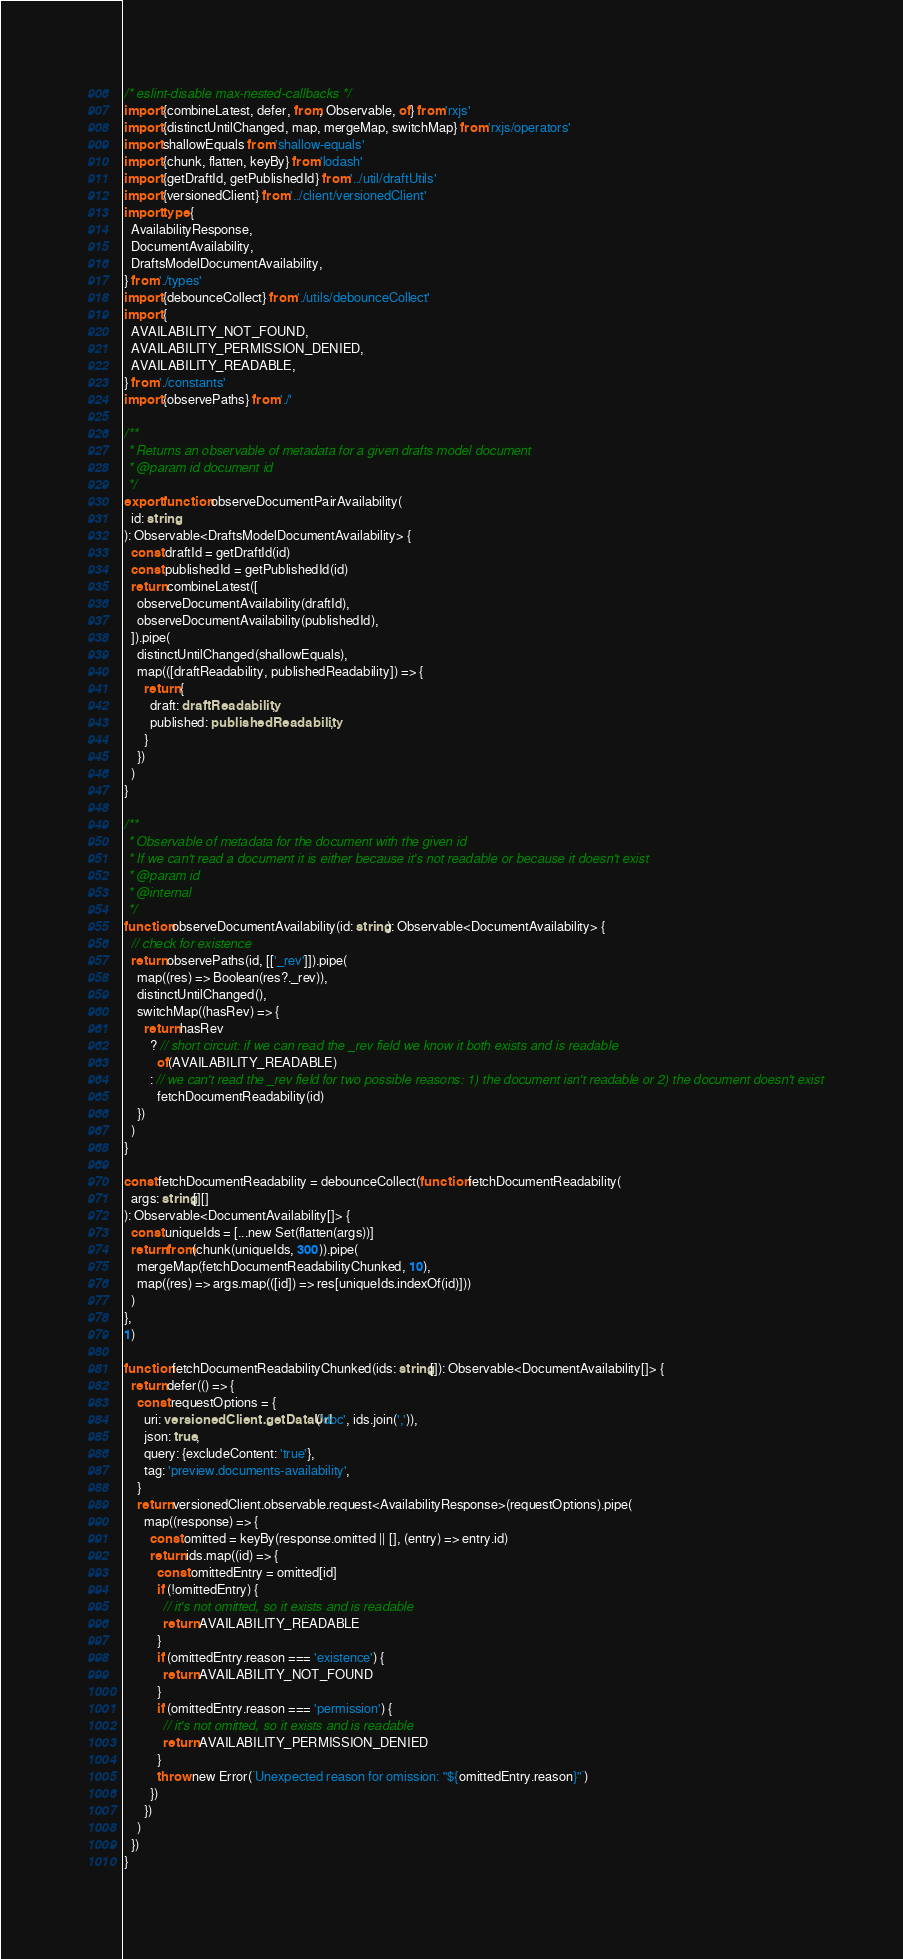<code> <loc_0><loc_0><loc_500><loc_500><_TypeScript_>/* eslint-disable max-nested-callbacks */
import {combineLatest, defer, from, Observable, of} from 'rxjs'
import {distinctUntilChanged, map, mergeMap, switchMap} from 'rxjs/operators'
import shallowEquals from 'shallow-equals'
import {chunk, flatten, keyBy} from 'lodash'
import {getDraftId, getPublishedId} from '../util/draftUtils'
import {versionedClient} from '../client/versionedClient'
import type {
  AvailabilityResponse,
  DocumentAvailability,
  DraftsModelDocumentAvailability,
} from './types'
import {debounceCollect} from './utils/debounceCollect'
import {
  AVAILABILITY_NOT_FOUND,
  AVAILABILITY_PERMISSION_DENIED,
  AVAILABILITY_READABLE,
} from './constants'
import {observePaths} from './'

/**
 * Returns an observable of metadata for a given drafts model document
 * @param id document id
 */
export function observeDocumentPairAvailability(
  id: string
): Observable<DraftsModelDocumentAvailability> {
  const draftId = getDraftId(id)
  const publishedId = getPublishedId(id)
  return combineLatest([
    observeDocumentAvailability(draftId),
    observeDocumentAvailability(publishedId),
  ]).pipe(
    distinctUntilChanged(shallowEquals),
    map(([draftReadability, publishedReadability]) => {
      return {
        draft: draftReadability,
        published: publishedReadability,
      }
    })
  )
}

/**
 * Observable of metadata for the document with the given id
 * If we can't read a document it is either because it's not readable or because it doesn't exist
 * @param id
 * @internal
 */
function observeDocumentAvailability(id: string): Observable<DocumentAvailability> {
  // check for existence
  return observePaths(id, [['_rev']]).pipe(
    map((res) => Boolean(res?._rev)),
    distinctUntilChanged(),
    switchMap((hasRev) => {
      return hasRev
        ? // short circuit: if we can read the _rev field we know it both exists and is readable
          of(AVAILABILITY_READABLE)
        : // we can't read the _rev field for two possible reasons: 1) the document isn't readable or 2) the document doesn't exist
          fetchDocumentReadability(id)
    })
  )
}

const fetchDocumentReadability = debounceCollect(function fetchDocumentReadability(
  args: string[][]
): Observable<DocumentAvailability[]> {
  const uniqueIds = [...new Set(flatten(args))]
  return from(chunk(uniqueIds, 300)).pipe(
    mergeMap(fetchDocumentReadabilityChunked, 10),
    map((res) => args.map(([id]) => res[uniqueIds.indexOf(id)]))
  )
},
1)

function fetchDocumentReadabilityChunked(ids: string[]): Observable<DocumentAvailability[]> {
  return defer(() => {
    const requestOptions = {
      uri: versionedClient.getDataUrl('doc', ids.join(',')),
      json: true,
      query: {excludeContent: 'true'},
      tag: 'preview.documents-availability',
    }
    return versionedClient.observable.request<AvailabilityResponse>(requestOptions).pipe(
      map((response) => {
        const omitted = keyBy(response.omitted || [], (entry) => entry.id)
        return ids.map((id) => {
          const omittedEntry = omitted[id]
          if (!omittedEntry) {
            // it's not omitted, so it exists and is readable
            return AVAILABILITY_READABLE
          }
          if (omittedEntry.reason === 'existence') {
            return AVAILABILITY_NOT_FOUND
          }
          if (omittedEntry.reason === 'permission') {
            // it's not omitted, so it exists and is readable
            return AVAILABILITY_PERMISSION_DENIED
          }
          throw new Error(`Unexpected reason for omission: "${omittedEntry.reason}"`)
        })
      })
    )
  })
}
</code> 